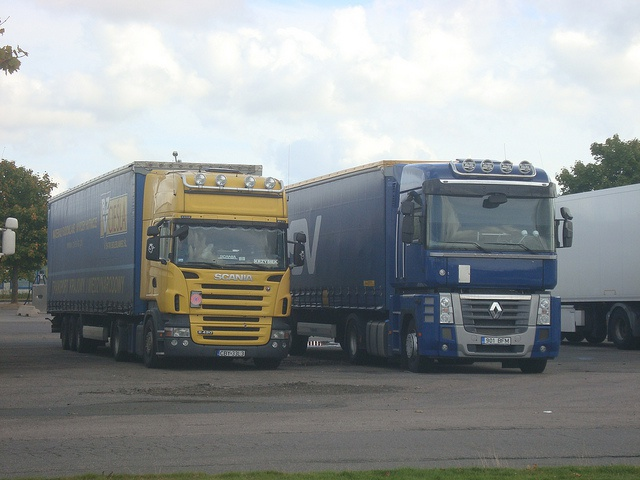Describe the objects in this image and their specific colors. I can see truck in lavender, gray, navy, black, and darkblue tones, truck in lavender, gray, black, tan, and darkgray tones, and truck in lavender, darkgray, black, and gray tones in this image. 